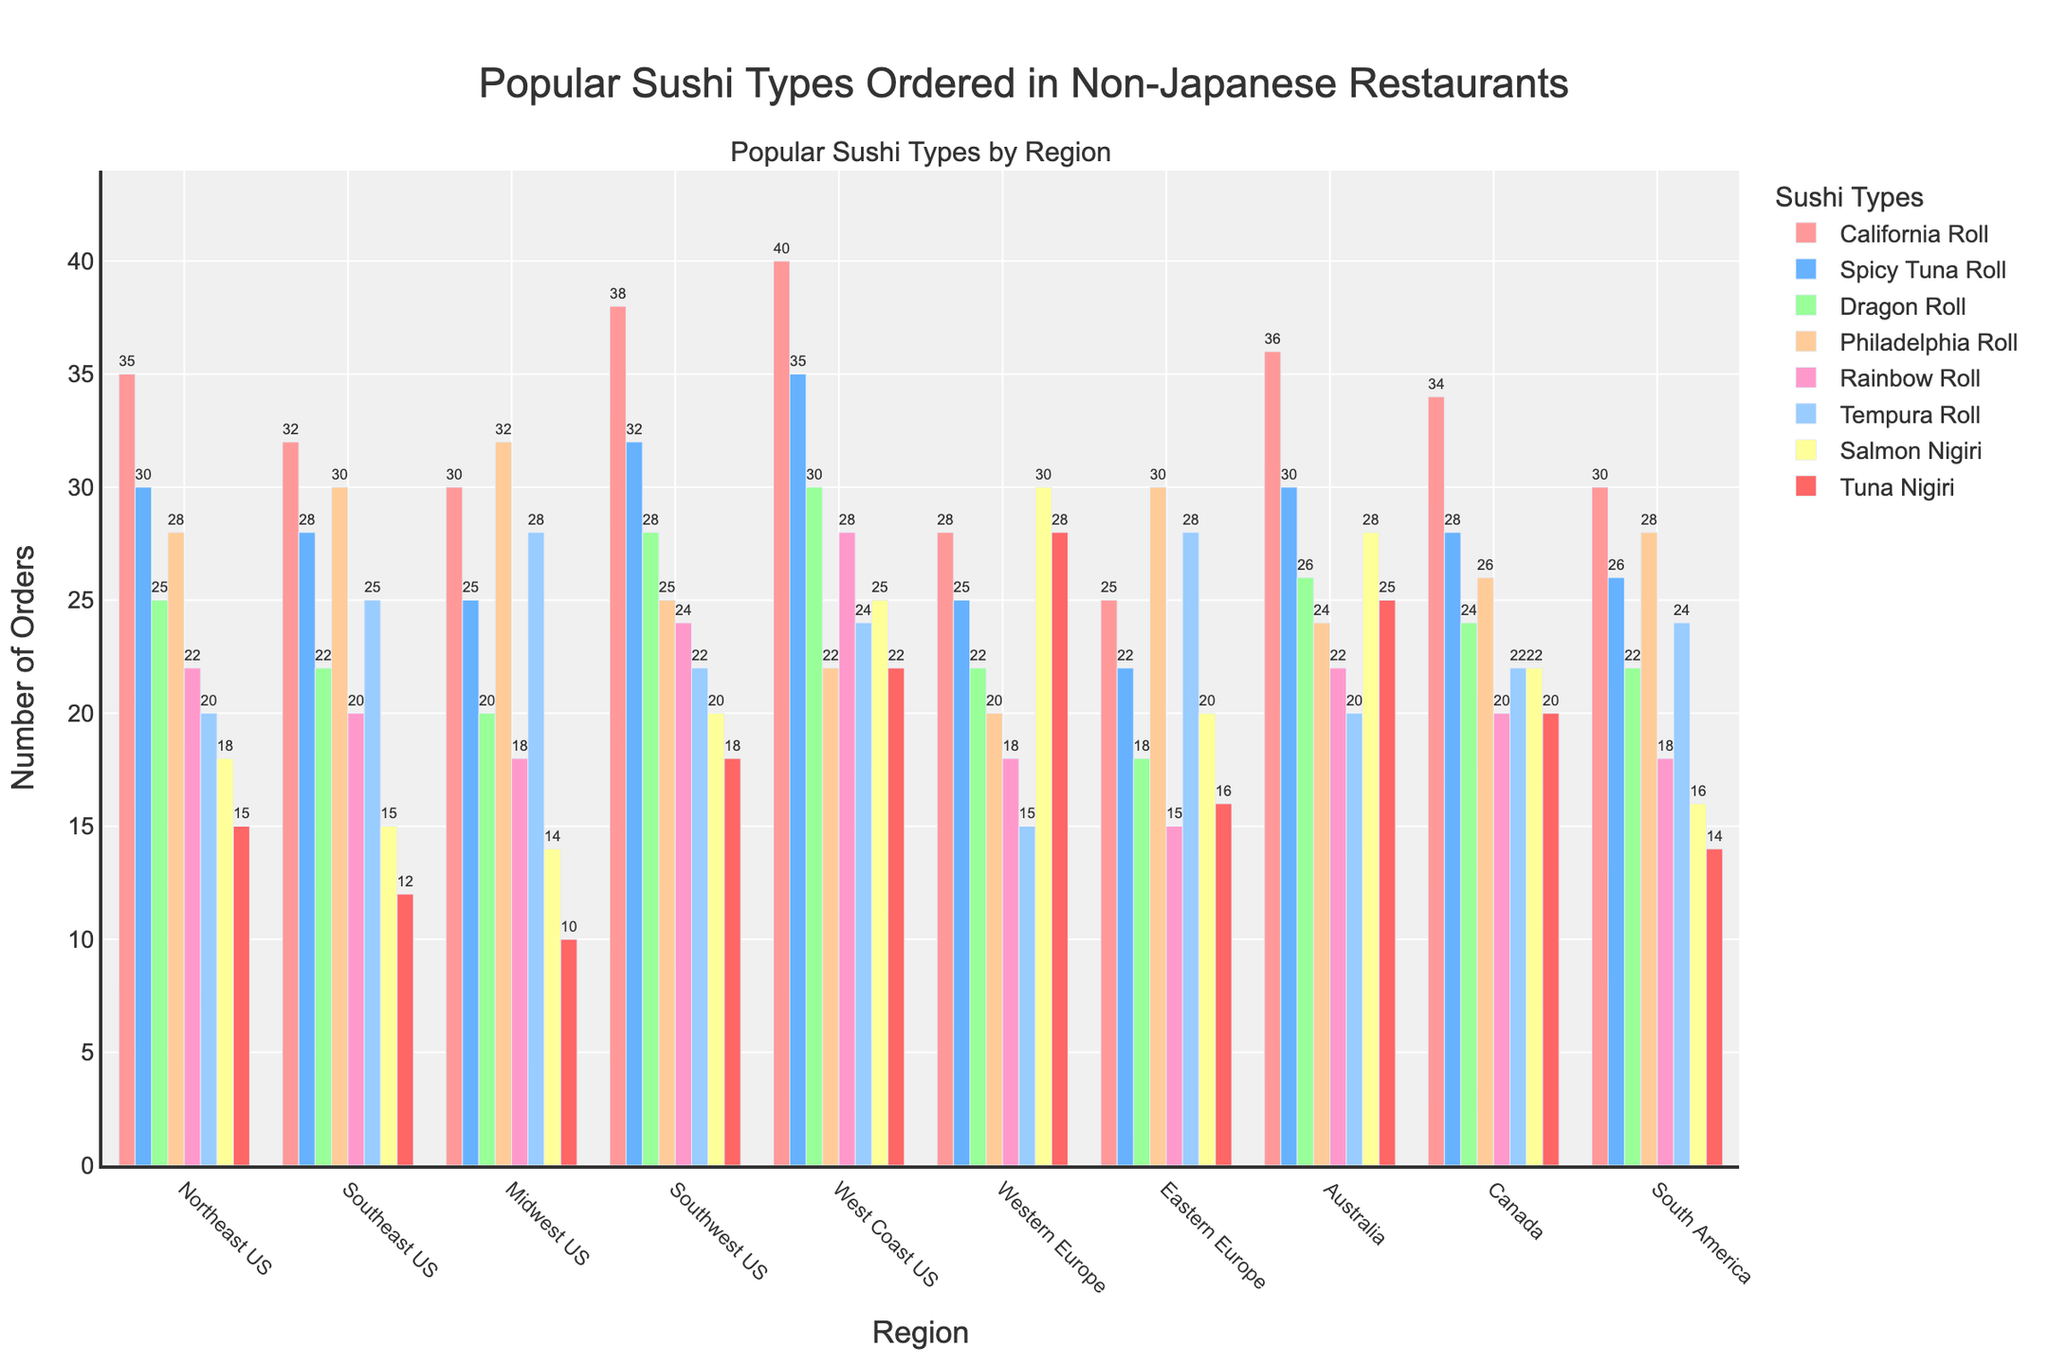Which region orders the most California Rolls? The tallest bar in the California Roll category corresponds to the West Coast US region, indicating it has the highest order count.
Answer: West Coast US Which sushi type has the highest number of orders in Western Europe? By comparing the heights of the bars for Western Europe, the Salmon Nigiri bar is the tallest.
Answer: Salmon Nigiri How many more Spicy Tuna Rolls are ordered in the West Coast US than in the Midwest US? According to the figure, the number of Spicy Tuna Rolls ordered in the West Coast US is 35, and in the Midwest US, it is 25. The difference is 35 - 25 = 10.
Answer: 10 What is the average number of Dragon Rolls ordered in the Northeast US, Midwest US, and Australia? Summing the values for Dragon Rolls in these regions (25+20+26) gives 71, and dividing by 3 yields an average of 71/3 ≈ 23.67.
Answer: 23.67 Which two regions have the least difference in orders of Philadelphia Rolls? The values for Philadelphia Rolls are compared across regions, and the Southeast US (30) and Eastern Europe (30) have the least difference, which is zero.
Answer: Southeast US and Eastern Europe In which region is the total number of ordered sushi types the highest? Sum the number of orders for all sushi types in each region. The West Coast US has the highest total: 40 + 35 + 30 + 22 + 28 + 24 + 25 + 22 = 226.
Answer: West Coast US What is the total number of Tempura Rolls ordered in the Northeast US and Southeast US combined? The figure shows 20 for the Northeast US and 25 for the Southeast US. Summing these gives 20 + 25 = 45.
Answer: 45 Which sushi type is ordered least in South America, and how many orders are there? The shortest bar for South America corresponds to Tuna Nigiri with 14 orders.
Answer: Tuna Nigiri with 14 orders What is the range of orders for Tuna Nigiri across all regions? The maximum orders for Tuna Nigiri are 28 in Western Europe and the minimum is 10 in the Midwest US. Hence, the range is 28 - 10 = 18.
Answer: 18 How many more California Rolls are ordered in the Southwest US compared to Australia? Southwest US has 38 and Australia has 36 for California Rolls, so the difference is 38 - 36 = 2.
Answer: 2 